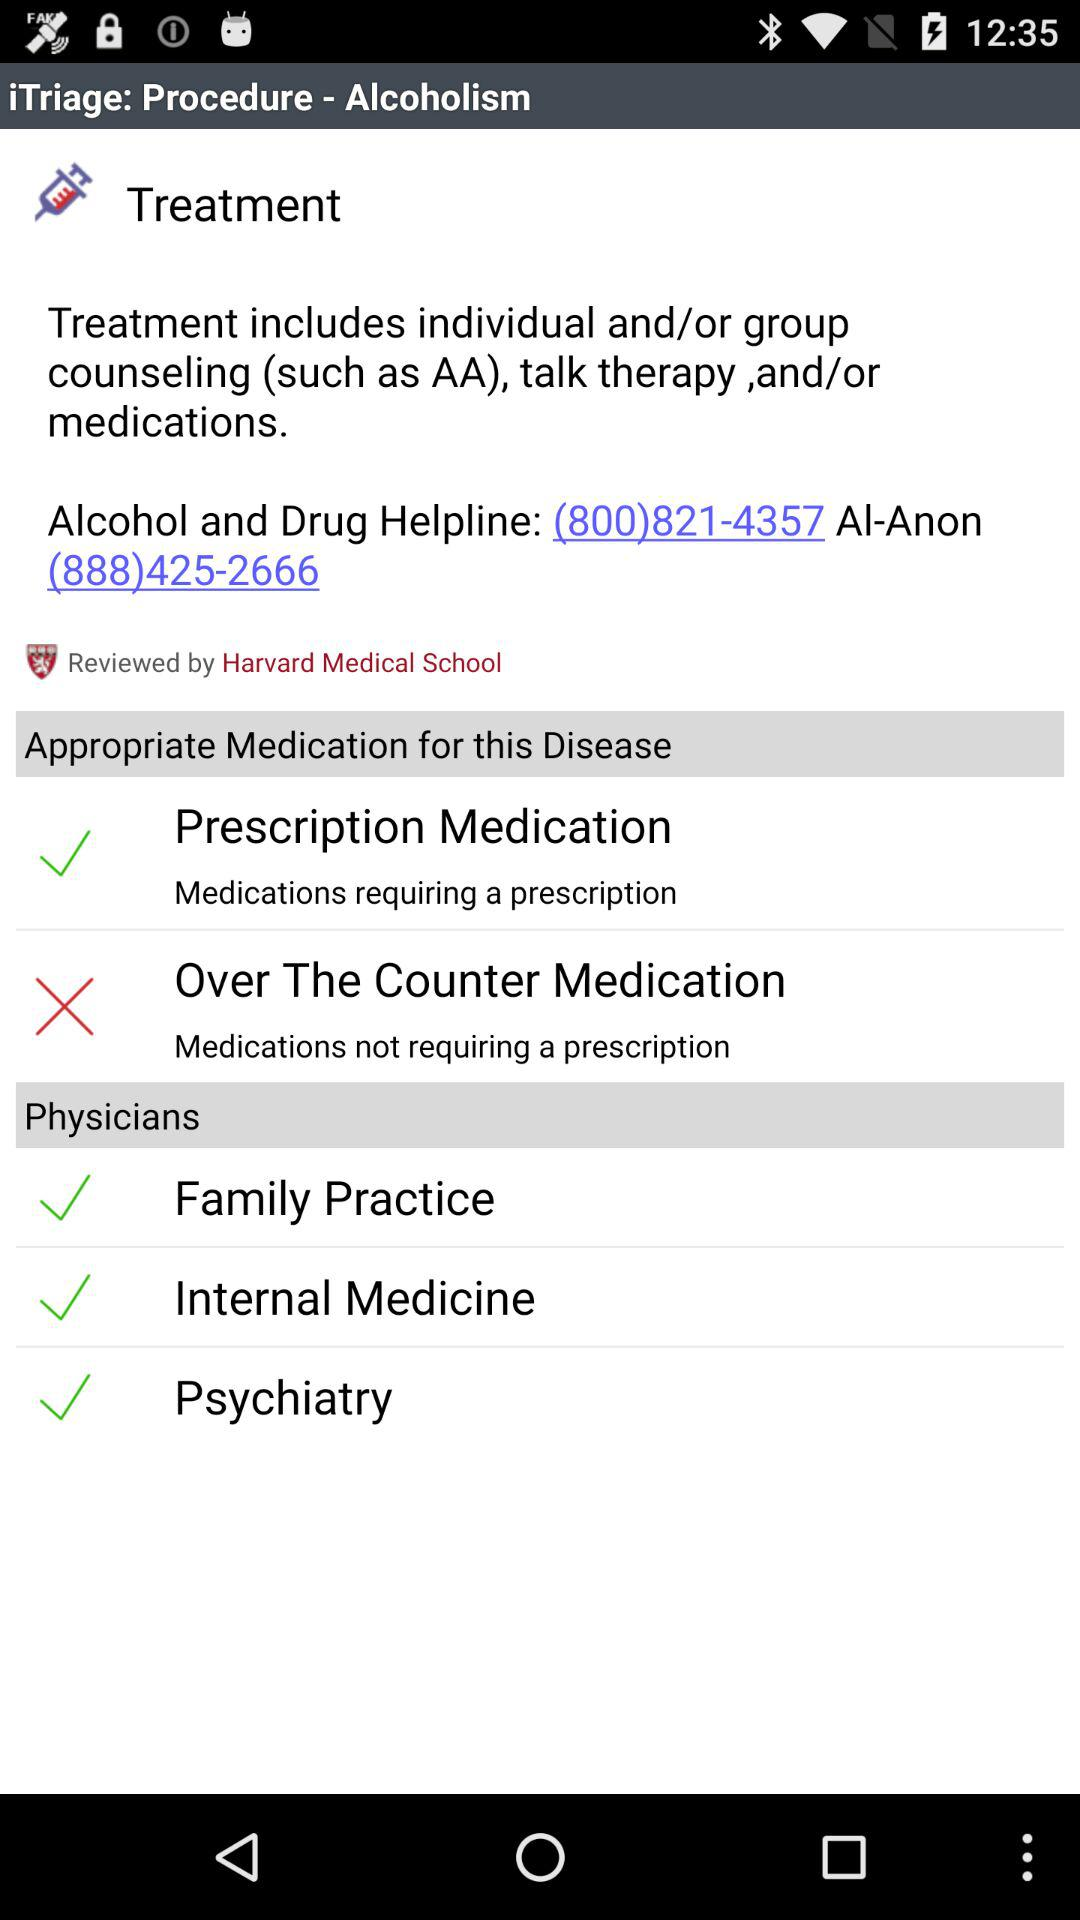What is the helpline number for "Alcohol and Drug"? The helpline number is (800) 821-4357. 